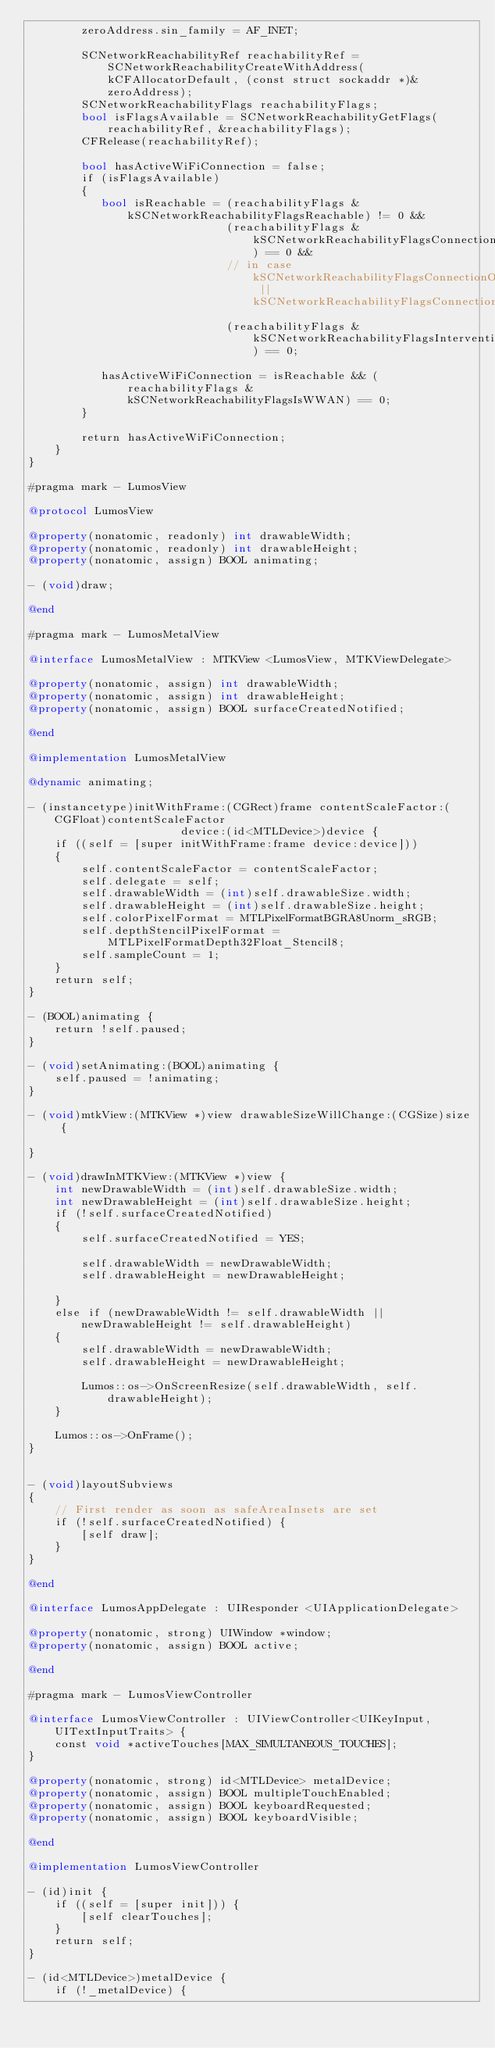Convert code to text. <code><loc_0><loc_0><loc_500><loc_500><_ObjectiveC_>        zeroAddress.sin_family = AF_INET;

        SCNetworkReachabilityRef reachabilityRef = SCNetworkReachabilityCreateWithAddress(kCFAllocatorDefault, (const struct sockaddr *)&zeroAddress);
        SCNetworkReachabilityFlags reachabilityFlags;
        bool isFlagsAvailable = SCNetworkReachabilityGetFlags(reachabilityRef, &reachabilityFlags);
        CFRelease(reachabilityRef);

        bool hasActiveWiFiConnection = false;
        if (isFlagsAvailable)
        {
           bool isReachable = (reachabilityFlags & kSCNetworkReachabilityFlagsReachable) != 0 &&
                              (reachabilityFlags & kSCNetworkReachabilityFlagsConnectionRequired) == 0 &&
                              // in case kSCNetworkReachabilityFlagsConnectionOnDemand || kSCNetworkReachabilityFlagsConnectionOnTraffic
                              (reachabilityFlags & kSCNetworkReachabilityFlagsInterventionRequired) == 0;
                       
           hasActiveWiFiConnection = isReachable && (reachabilityFlags & kSCNetworkReachabilityFlagsIsWWAN) == 0;
        }

        return hasActiveWiFiConnection;
    }
}

#pragma mark - LumosView

@protocol LumosView

@property(nonatomic, readonly) int drawableWidth;
@property(nonatomic, readonly) int drawableHeight;
@property(nonatomic, assign) BOOL animating;

- (void)draw;

@end

#pragma mark - LumosMetalView

@interface LumosMetalView : MTKView <LumosView, MTKViewDelegate>

@property(nonatomic, assign) int drawableWidth;
@property(nonatomic, assign) int drawableHeight;
@property(nonatomic, assign) BOOL surfaceCreatedNotified;

@end

@implementation LumosMetalView

@dynamic animating;

- (instancetype)initWithFrame:(CGRect)frame contentScaleFactor:(CGFloat)contentScaleFactor
                       device:(id<MTLDevice>)device {
    if ((self = [super initWithFrame:frame device:device]))
    {
        self.contentScaleFactor = contentScaleFactor;
        self.delegate = self;
        self.drawableWidth = (int)self.drawableSize.width;
        self.drawableHeight = (int)self.drawableSize.height;
        self.colorPixelFormat = MTLPixelFormatBGRA8Unorm_sRGB;
        self.depthStencilPixelFormat = MTLPixelFormatDepth32Float_Stencil8;
        self.sampleCount = 1;
    }
    return self;
}

- (BOOL)animating {
    return !self.paused;
}

- (void)setAnimating:(BOOL)animating {
    self.paused = !animating;
}

- (void)mtkView:(MTKView *)view drawableSizeWillChange:(CGSize)size {
    
}

- (void)drawInMTKView:(MTKView *)view {
    int newDrawableWidth = (int)self.drawableSize.width;
    int newDrawableHeight = (int)self.drawableSize.height;
    if (!self.surfaceCreatedNotified)
    {
        self.surfaceCreatedNotified = YES;

        self.drawableWidth = newDrawableWidth;
        self.drawableHeight = newDrawableHeight;
    
    }
    else if (newDrawableWidth != self.drawableWidth || newDrawableHeight != self.drawableHeight)
    {
        self.drawableWidth = newDrawableWidth;
        self.drawableHeight = newDrawableHeight;
        
        Lumos::os->OnScreenResize(self.drawableWidth, self.drawableHeight);
    }
        
    Lumos::os->OnFrame();
}
    

- (void)layoutSubviews
{
    // First render as soon as safeAreaInsets are set
    if (!self.surfaceCreatedNotified) {
        [self draw];
    }
}

@end

@interface LumosAppDelegate : UIResponder <UIApplicationDelegate>

@property(nonatomic, strong) UIWindow *window;
@property(nonatomic, assign) BOOL active;

@end

#pragma mark - LumosViewController

@interface LumosViewController : UIViewController<UIKeyInput, UITextInputTraits> {
    const void *activeTouches[MAX_SIMULTANEOUS_TOUCHES];
}

@property(nonatomic, strong) id<MTLDevice> metalDevice;
@property(nonatomic, assign) BOOL multipleTouchEnabled;
@property(nonatomic, assign) BOOL keyboardRequested;
@property(nonatomic, assign) BOOL keyboardVisible;

@end

@implementation LumosViewController

- (id)init {
    if ((self = [super init])) {
        [self clearTouches];
    }
    return self;
}

- (id<MTLDevice>)metalDevice {
    if (!_metalDevice) {</code> 